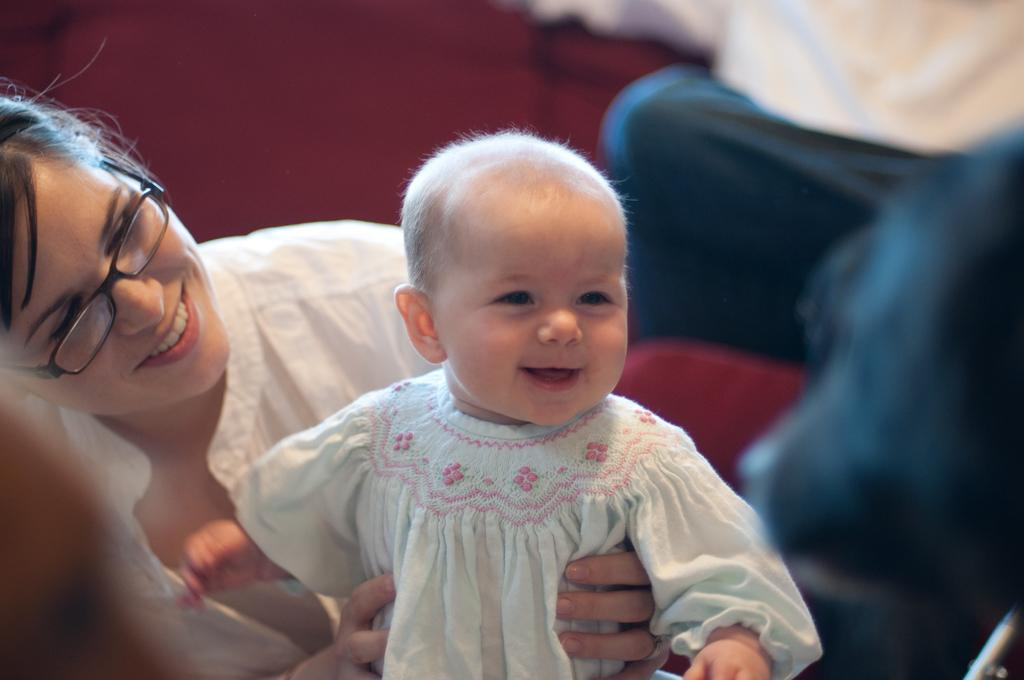What is the main subject of the image? There is a beautiful woman in the image. What is the woman doing in the image? The woman is holding a baby. What is the woman wearing in the image? The woman is wearing a white color shirt. What is the baby wearing in the image? The baby is wearing a white color dress. What is the emotional expression of the woman and the baby in the image? Both the woman and the baby are smiling. Where are the scissors located in the image? There are no scissors present in the image. What type of shape is the baby making in the image? The baby is not making any specific shape in the image; they are simply being held by the woman. 